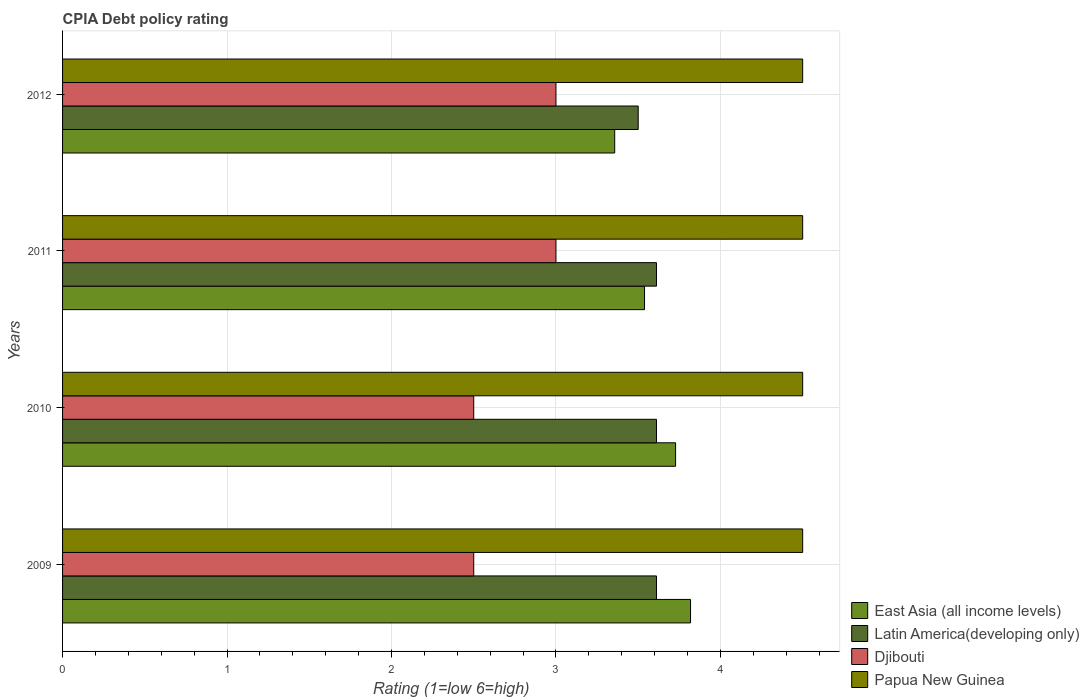How many different coloured bars are there?
Provide a succinct answer. 4. How many groups of bars are there?
Offer a very short reply. 4. Are the number of bars on each tick of the Y-axis equal?
Your answer should be compact. Yes. How many bars are there on the 1st tick from the top?
Provide a short and direct response. 4. Across all years, what is the maximum CPIA rating in Latin America(developing only)?
Make the answer very short. 3.61. In which year was the CPIA rating in Papua New Guinea minimum?
Your answer should be very brief. 2009. What is the total CPIA rating in Latin America(developing only) in the graph?
Offer a very short reply. 14.33. What is the difference between the CPIA rating in East Asia (all income levels) in 2009 and that in 2010?
Give a very brief answer. 0.09. What is the difference between the CPIA rating in East Asia (all income levels) in 2010 and the CPIA rating in Papua New Guinea in 2009?
Offer a very short reply. -0.77. What is the average CPIA rating in East Asia (all income levels) per year?
Offer a very short reply. 3.61. In the year 2010, what is the difference between the CPIA rating in Djibouti and CPIA rating in Latin America(developing only)?
Your answer should be very brief. -1.11. In how many years, is the CPIA rating in East Asia (all income levels) greater than 4.4 ?
Make the answer very short. 0. What is the ratio of the CPIA rating in East Asia (all income levels) in 2011 to that in 2012?
Your response must be concise. 1.05. Is the difference between the CPIA rating in Djibouti in 2010 and 2012 greater than the difference between the CPIA rating in Latin America(developing only) in 2010 and 2012?
Your answer should be very brief. No. What is the difference between the highest and the lowest CPIA rating in Papua New Guinea?
Your answer should be compact. 0. In how many years, is the CPIA rating in Latin America(developing only) greater than the average CPIA rating in Latin America(developing only) taken over all years?
Keep it short and to the point. 3. Is the sum of the CPIA rating in Papua New Guinea in 2010 and 2011 greater than the maximum CPIA rating in Djibouti across all years?
Ensure brevity in your answer.  Yes. Is it the case that in every year, the sum of the CPIA rating in Djibouti and CPIA rating in Latin America(developing only) is greater than the sum of CPIA rating in East Asia (all income levels) and CPIA rating in Papua New Guinea?
Offer a very short reply. No. What does the 4th bar from the top in 2011 represents?
Your answer should be compact. East Asia (all income levels). What does the 4th bar from the bottom in 2009 represents?
Your answer should be very brief. Papua New Guinea. Are all the bars in the graph horizontal?
Offer a very short reply. Yes. Are the values on the major ticks of X-axis written in scientific E-notation?
Your response must be concise. No. Does the graph contain grids?
Offer a very short reply. Yes. Where does the legend appear in the graph?
Offer a very short reply. Bottom right. What is the title of the graph?
Your answer should be very brief. CPIA Debt policy rating. Does "Czech Republic" appear as one of the legend labels in the graph?
Give a very brief answer. No. What is the Rating (1=low 6=high) in East Asia (all income levels) in 2009?
Ensure brevity in your answer.  3.82. What is the Rating (1=low 6=high) of Latin America(developing only) in 2009?
Your response must be concise. 3.61. What is the Rating (1=low 6=high) of Djibouti in 2009?
Keep it short and to the point. 2.5. What is the Rating (1=low 6=high) of East Asia (all income levels) in 2010?
Your answer should be very brief. 3.73. What is the Rating (1=low 6=high) in Latin America(developing only) in 2010?
Your response must be concise. 3.61. What is the Rating (1=low 6=high) of Papua New Guinea in 2010?
Your answer should be compact. 4.5. What is the Rating (1=low 6=high) in East Asia (all income levels) in 2011?
Make the answer very short. 3.54. What is the Rating (1=low 6=high) of Latin America(developing only) in 2011?
Offer a very short reply. 3.61. What is the Rating (1=low 6=high) of Djibouti in 2011?
Keep it short and to the point. 3. What is the Rating (1=low 6=high) in East Asia (all income levels) in 2012?
Provide a short and direct response. 3.36. What is the Rating (1=low 6=high) of Papua New Guinea in 2012?
Provide a succinct answer. 4.5. Across all years, what is the maximum Rating (1=low 6=high) in East Asia (all income levels)?
Make the answer very short. 3.82. Across all years, what is the maximum Rating (1=low 6=high) in Latin America(developing only)?
Provide a succinct answer. 3.61. Across all years, what is the maximum Rating (1=low 6=high) of Djibouti?
Make the answer very short. 3. Across all years, what is the minimum Rating (1=low 6=high) in East Asia (all income levels)?
Keep it short and to the point. 3.36. Across all years, what is the minimum Rating (1=low 6=high) in Djibouti?
Provide a succinct answer. 2.5. What is the total Rating (1=low 6=high) of East Asia (all income levels) in the graph?
Keep it short and to the point. 14.44. What is the total Rating (1=low 6=high) of Latin America(developing only) in the graph?
Your answer should be compact. 14.33. What is the total Rating (1=low 6=high) of Papua New Guinea in the graph?
Offer a terse response. 18. What is the difference between the Rating (1=low 6=high) in East Asia (all income levels) in 2009 and that in 2010?
Keep it short and to the point. 0.09. What is the difference between the Rating (1=low 6=high) in Latin America(developing only) in 2009 and that in 2010?
Ensure brevity in your answer.  0. What is the difference between the Rating (1=low 6=high) of Papua New Guinea in 2009 and that in 2010?
Keep it short and to the point. 0. What is the difference between the Rating (1=low 6=high) in East Asia (all income levels) in 2009 and that in 2011?
Offer a terse response. 0.28. What is the difference between the Rating (1=low 6=high) of Djibouti in 2009 and that in 2011?
Ensure brevity in your answer.  -0.5. What is the difference between the Rating (1=low 6=high) of Papua New Guinea in 2009 and that in 2011?
Ensure brevity in your answer.  0. What is the difference between the Rating (1=low 6=high) in East Asia (all income levels) in 2009 and that in 2012?
Keep it short and to the point. 0.46. What is the difference between the Rating (1=low 6=high) in East Asia (all income levels) in 2010 and that in 2011?
Your response must be concise. 0.19. What is the difference between the Rating (1=low 6=high) of Latin America(developing only) in 2010 and that in 2011?
Make the answer very short. 0. What is the difference between the Rating (1=low 6=high) of Djibouti in 2010 and that in 2011?
Give a very brief answer. -0.5. What is the difference between the Rating (1=low 6=high) in Papua New Guinea in 2010 and that in 2011?
Your answer should be very brief. 0. What is the difference between the Rating (1=low 6=high) of East Asia (all income levels) in 2010 and that in 2012?
Ensure brevity in your answer.  0.37. What is the difference between the Rating (1=low 6=high) of Latin America(developing only) in 2010 and that in 2012?
Offer a terse response. 0.11. What is the difference between the Rating (1=low 6=high) in East Asia (all income levels) in 2011 and that in 2012?
Ensure brevity in your answer.  0.18. What is the difference between the Rating (1=low 6=high) in Latin America(developing only) in 2011 and that in 2012?
Give a very brief answer. 0.11. What is the difference between the Rating (1=low 6=high) of East Asia (all income levels) in 2009 and the Rating (1=low 6=high) of Latin America(developing only) in 2010?
Make the answer very short. 0.21. What is the difference between the Rating (1=low 6=high) of East Asia (all income levels) in 2009 and the Rating (1=low 6=high) of Djibouti in 2010?
Offer a terse response. 1.32. What is the difference between the Rating (1=low 6=high) of East Asia (all income levels) in 2009 and the Rating (1=low 6=high) of Papua New Guinea in 2010?
Your response must be concise. -0.68. What is the difference between the Rating (1=low 6=high) in Latin America(developing only) in 2009 and the Rating (1=low 6=high) in Papua New Guinea in 2010?
Give a very brief answer. -0.89. What is the difference between the Rating (1=low 6=high) of East Asia (all income levels) in 2009 and the Rating (1=low 6=high) of Latin America(developing only) in 2011?
Your answer should be compact. 0.21. What is the difference between the Rating (1=low 6=high) of East Asia (all income levels) in 2009 and the Rating (1=low 6=high) of Djibouti in 2011?
Make the answer very short. 0.82. What is the difference between the Rating (1=low 6=high) in East Asia (all income levels) in 2009 and the Rating (1=low 6=high) in Papua New Guinea in 2011?
Your response must be concise. -0.68. What is the difference between the Rating (1=low 6=high) of Latin America(developing only) in 2009 and the Rating (1=low 6=high) of Djibouti in 2011?
Your response must be concise. 0.61. What is the difference between the Rating (1=low 6=high) of Latin America(developing only) in 2009 and the Rating (1=low 6=high) of Papua New Guinea in 2011?
Offer a very short reply. -0.89. What is the difference between the Rating (1=low 6=high) in East Asia (all income levels) in 2009 and the Rating (1=low 6=high) in Latin America(developing only) in 2012?
Your response must be concise. 0.32. What is the difference between the Rating (1=low 6=high) of East Asia (all income levels) in 2009 and the Rating (1=low 6=high) of Djibouti in 2012?
Offer a terse response. 0.82. What is the difference between the Rating (1=low 6=high) in East Asia (all income levels) in 2009 and the Rating (1=low 6=high) in Papua New Guinea in 2012?
Make the answer very short. -0.68. What is the difference between the Rating (1=low 6=high) of Latin America(developing only) in 2009 and the Rating (1=low 6=high) of Djibouti in 2012?
Provide a succinct answer. 0.61. What is the difference between the Rating (1=low 6=high) of Latin America(developing only) in 2009 and the Rating (1=low 6=high) of Papua New Guinea in 2012?
Give a very brief answer. -0.89. What is the difference between the Rating (1=low 6=high) in East Asia (all income levels) in 2010 and the Rating (1=low 6=high) in Latin America(developing only) in 2011?
Ensure brevity in your answer.  0.12. What is the difference between the Rating (1=low 6=high) of East Asia (all income levels) in 2010 and the Rating (1=low 6=high) of Djibouti in 2011?
Your answer should be compact. 0.73. What is the difference between the Rating (1=low 6=high) of East Asia (all income levels) in 2010 and the Rating (1=low 6=high) of Papua New Guinea in 2011?
Make the answer very short. -0.77. What is the difference between the Rating (1=low 6=high) of Latin America(developing only) in 2010 and the Rating (1=low 6=high) of Djibouti in 2011?
Your answer should be very brief. 0.61. What is the difference between the Rating (1=low 6=high) in Latin America(developing only) in 2010 and the Rating (1=low 6=high) in Papua New Guinea in 2011?
Your answer should be compact. -0.89. What is the difference between the Rating (1=low 6=high) in East Asia (all income levels) in 2010 and the Rating (1=low 6=high) in Latin America(developing only) in 2012?
Give a very brief answer. 0.23. What is the difference between the Rating (1=low 6=high) of East Asia (all income levels) in 2010 and the Rating (1=low 6=high) of Djibouti in 2012?
Keep it short and to the point. 0.73. What is the difference between the Rating (1=low 6=high) of East Asia (all income levels) in 2010 and the Rating (1=low 6=high) of Papua New Guinea in 2012?
Give a very brief answer. -0.77. What is the difference between the Rating (1=low 6=high) in Latin America(developing only) in 2010 and the Rating (1=low 6=high) in Djibouti in 2012?
Give a very brief answer. 0.61. What is the difference between the Rating (1=low 6=high) in Latin America(developing only) in 2010 and the Rating (1=low 6=high) in Papua New Guinea in 2012?
Keep it short and to the point. -0.89. What is the difference between the Rating (1=low 6=high) of Djibouti in 2010 and the Rating (1=low 6=high) of Papua New Guinea in 2012?
Ensure brevity in your answer.  -2. What is the difference between the Rating (1=low 6=high) of East Asia (all income levels) in 2011 and the Rating (1=low 6=high) of Latin America(developing only) in 2012?
Make the answer very short. 0.04. What is the difference between the Rating (1=low 6=high) in East Asia (all income levels) in 2011 and the Rating (1=low 6=high) in Djibouti in 2012?
Provide a short and direct response. 0.54. What is the difference between the Rating (1=low 6=high) in East Asia (all income levels) in 2011 and the Rating (1=low 6=high) in Papua New Guinea in 2012?
Your answer should be compact. -0.96. What is the difference between the Rating (1=low 6=high) in Latin America(developing only) in 2011 and the Rating (1=low 6=high) in Djibouti in 2012?
Your answer should be very brief. 0.61. What is the difference between the Rating (1=low 6=high) of Latin America(developing only) in 2011 and the Rating (1=low 6=high) of Papua New Guinea in 2012?
Ensure brevity in your answer.  -0.89. What is the average Rating (1=low 6=high) in East Asia (all income levels) per year?
Offer a very short reply. 3.61. What is the average Rating (1=low 6=high) of Latin America(developing only) per year?
Offer a very short reply. 3.58. What is the average Rating (1=low 6=high) of Djibouti per year?
Your answer should be compact. 2.75. In the year 2009, what is the difference between the Rating (1=low 6=high) in East Asia (all income levels) and Rating (1=low 6=high) in Latin America(developing only)?
Your answer should be compact. 0.21. In the year 2009, what is the difference between the Rating (1=low 6=high) of East Asia (all income levels) and Rating (1=low 6=high) of Djibouti?
Ensure brevity in your answer.  1.32. In the year 2009, what is the difference between the Rating (1=low 6=high) of East Asia (all income levels) and Rating (1=low 6=high) of Papua New Guinea?
Provide a short and direct response. -0.68. In the year 2009, what is the difference between the Rating (1=low 6=high) of Latin America(developing only) and Rating (1=low 6=high) of Djibouti?
Offer a terse response. 1.11. In the year 2009, what is the difference between the Rating (1=low 6=high) in Latin America(developing only) and Rating (1=low 6=high) in Papua New Guinea?
Offer a terse response. -0.89. In the year 2009, what is the difference between the Rating (1=low 6=high) of Djibouti and Rating (1=low 6=high) of Papua New Guinea?
Offer a very short reply. -2. In the year 2010, what is the difference between the Rating (1=low 6=high) of East Asia (all income levels) and Rating (1=low 6=high) of Latin America(developing only)?
Your answer should be compact. 0.12. In the year 2010, what is the difference between the Rating (1=low 6=high) in East Asia (all income levels) and Rating (1=low 6=high) in Djibouti?
Ensure brevity in your answer.  1.23. In the year 2010, what is the difference between the Rating (1=low 6=high) of East Asia (all income levels) and Rating (1=low 6=high) of Papua New Guinea?
Give a very brief answer. -0.77. In the year 2010, what is the difference between the Rating (1=low 6=high) of Latin America(developing only) and Rating (1=low 6=high) of Papua New Guinea?
Offer a terse response. -0.89. In the year 2010, what is the difference between the Rating (1=low 6=high) of Djibouti and Rating (1=low 6=high) of Papua New Guinea?
Offer a very short reply. -2. In the year 2011, what is the difference between the Rating (1=low 6=high) of East Asia (all income levels) and Rating (1=low 6=high) of Latin America(developing only)?
Provide a succinct answer. -0.07. In the year 2011, what is the difference between the Rating (1=low 6=high) in East Asia (all income levels) and Rating (1=low 6=high) in Djibouti?
Your answer should be very brief. 0.54. In the year 2011, what is the difference between the Rating (1=low 6=high) of East Asia (all income levels) and Rating (1=low 6=high) of Papua New Guinea?
Ensure brevity in your answer.  -0.96. In the year 2011, what is the difference between the Rating (1=low 6=high) of Latin America(developing only) and Rating (1=low 6=high) of Djibouti?
Your answer should be very brief. 0.61. In the year 2011, what is the difference between the Rating (1=low 6=high) in Latin America(developing only) and Rating (1=low 6=high) in Papua New Guinea?
Make the answer very short. -0.89. In the year 2011, what is the difference between the Rating (1=low 6=high) in Djibouti and Rating (1=low 6=high) in Papua New Guinea?
Your answer should be compact. -1.5. In the year 2012, what is the difference between the Rating (1=low 6=high) in East Asia (all income levels) and Rating (1=low 6=high) in Latin America(developing only)?
Your answer should be compact. -0.14. In the year 2012, what is the difference between the Rating (1=low 6=high) of East Asia (all income levels) and Rating (1=low 6=high) of Djibouti?
Your answer should be very brief. 0.36. In the year 2012, what is the difference between the Rating (1=low 6=high) in East Asia (all income levels) and Rating (1=low 6=high) in Papua New Guinea?
Your response must be concise. -1.14. In the year 2012, what is the difference between the Rating (1=low 6=high) of Latin America(developing only) and Rating (1=low 6=high) of Djibouti?
Provide a short and direct response. 0.5. In the year 2012, what is the difference between the Rating (1=low 6=high) of Latin America(developing only) and Rating (1=low 6=high) of Papua New Guinea?
Give a very brief answer. -1. In the year 2012, what is the difference between the Rating (1=low 6=high) of Djibouti and Rating (1=low 6=high) of Papua New Guinea?
Your answer should be very brief. -1.5. What is the ratio of the Rating (1=low 6=high) of East Asia (all income levels) in 2009 to that in 2010?
Keep it short and to the point. 1.02. What is the ratio of the Rating (1=low 6=high) of Papua New Guinea in 2009 to that in 2010?
Keep it short and to the point. 1. What is the ratio of the Rating (1=low 6=high) of East Asia (all income levels) in 2009 to that in 2011?
Your answer should be compact. 1.08. What is the ratio of the Rating (1=low 6=high) in Latin America(developing only) in 2009 to that in 2011?
Offer a very short reply. 1. What is the ratio of the Rating (1=low 6=high) in Djibouti in 2009 to that in 2011?
Your response must be concise. 0.83. What is the ratio of the Rating (1=low 6=high) of Papua New Guinea in 2009 to that in 2011?
Give a very brief answer. 1. What is the ratio of the Rating (1=low 6=high) in East Asia (all income levels) in 2009 to that in 2012?
Provide a short and direct response. 1.14. What is the ratio of the Rating (1=low 6=high) of Latin America(developing only) in 2009 to that in 2012?
Offer a very short reply. 1.03. What is the ratio of the Rating (1=low 6=high) of Papua New Guinea in 2009 to that in 2012?
Give a very brief answer. 1. What is the ratio of the Rating (1=low 6=high) of East Asia (all income levels) in 2010 to that in 2011?
Give a very brief answer. 1.05. What is the ratio of the Rating (1=low 6=high) of Djibouti in 2010 to that in 2011?
Make the answer very short. 0.83. What is the ratio of the Rating (1=low 6=high) of East Asia (all income levels) in 2010 to that in 2012?
Keep it short and to the point. 1.11. What is the ratio of the Rating (1=low 6=high) of Latin America(developing only) in 2010 to that in 2012?
Your answer should be compact. 1.03. What is the ratio of the Rating (1=low 6=high) in Djibouti in 2010 to that in 2012?
Keep it short and to the point. 0.83. What is the ratio of the Rating (1=low 6=high) in Papua New Guinea in 2010 to that in 2012?
Provide a short and direct response. 1. What is the ratio of the Rating (1=low 6=high) in East Asia (all income levels) in 2011 to that in 2012?
Keep it short and to the point. 1.05. What is the ratio of the Rating (1=low 6=high) of Latin America(developing only) in 2011 to that in 2012?
Keep it short and to the point. 1.03. What is the difference between the highest and the second highest Rating (1=low 6=high) in East Asia (all income levels)?
Your answer should be compact. 0.09. What is the difference between the highest and the second highest Rating (1=low 6=high) of Latin America(developing only)?
Provide a short and direct response. 0. What is the difference between the highest and the second highest Rating (1=low 6=high) of Djibouti?
Provide a succinct answer. 0. What is the difference between the highest and the lowest Rating (1=low 6=high) of East Asia (all income levels)?
Make the answer very short. 0.46. What is the difference between the highest and the lowest Rating (1=low 6=high) of Latin America(developing only)?
Your answer should be compact. 0.11. 